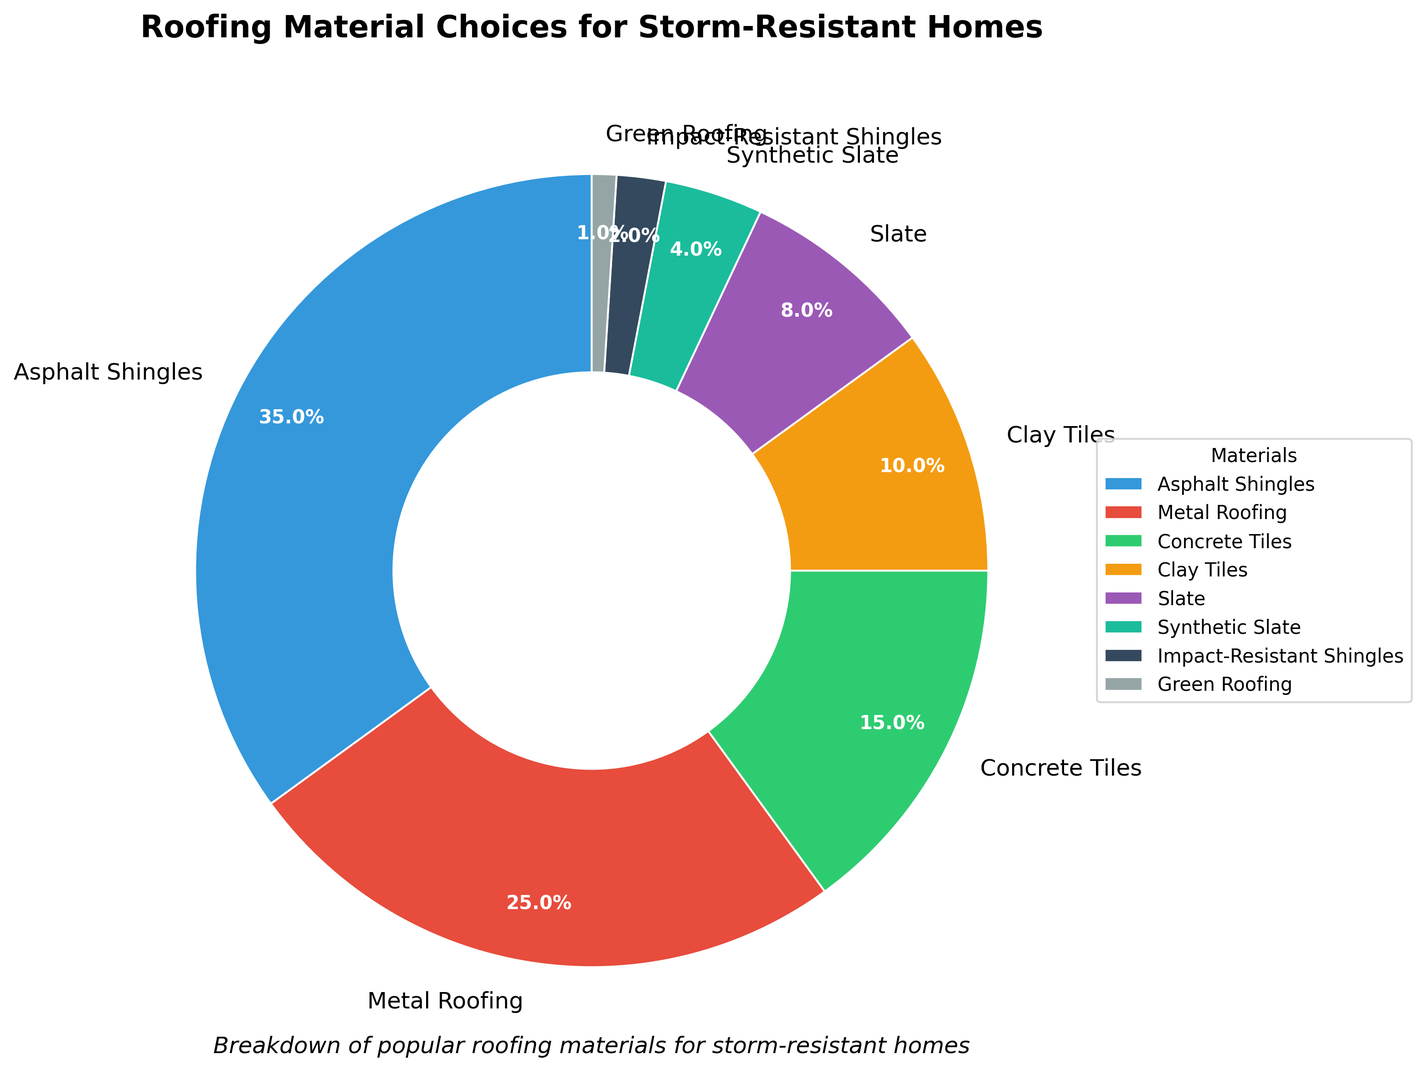What's the most popular material choice for storm-resistant homes? The figure's largest wedge indicates the most popular roofing material, which is labeled accordingly. Asphalt Shingles cover the largest area in the pie chart.
Answer: Asphalt Shingles Which roofing material occupies the third-largest percentage in the chart? To find the third-largest segment, first identify the largest (Asphalt Shingles), followed by the second-largest (Metal Roofing). The third-largest is the next in size, labeled as Concrete Tiles.
Answer: Concrete Tiles Which roofing material is twice as prevalent as Slate? To determine which material is twice as prevalent as Slate, we find Slate's percentage (8%). Doubling this gives 16%, but none me, the closest is Concrete Tiles at 15%, followed closely by Metal Roofing at 25%. Metal Roofing is more than twice as prevalent as Slate.
Answer: Metal Roofing Is Green Roofing more common than Synthetic Slate? We compare the sections labeled Green Roofing and Synthetic Slate. Green Roofing occupies 1%, while Synthetic Slate occupies 4%. Hence, Synthetic Slate is more common than Green Roofing.
Answer: No By how much does the percentage of Asphalt Shingles exceed that of Metal Roofing? The percentage for Asphalt Shingles is 35%, and for Metal Roofing, it's 25%. Subtract Metal Roofing's percentage from Asphalt Shingles'. The difference is 35% - 25%.
Answer: 10% What is the combined percentage of Concrete Tiles and Clay Tiles? Add the percentages of Concrete Tiles (15%) and Clay Tiles (10%). The sum is 15% + 10%.
Answer: 25% Which material ranks lowest in popularity among the choices? The smallest wedge represents the least popular material. The chart shows that Green Roofing is labeled with the smallest percentage.
Answer: Green Roofing What percentage do Impact-Resistant Shingles contribute to the chart? The section labeled Impact-Resistant Shingles indicates its percentage contribution.
Answer: 2% How does the percentage of Slate compare with Synthetic Slate? Compare the sections labeled Slate and Synthetic Slate. Slate takes up 8%, while Synthetic Slate takes up 4%. Therefore, Slate's percentage is double that of Synthetic Slate.
Answer: Slate is greater What's the total percentage of the three least common materials? Identify the three smallest percentage sections: Green Roofing (1%), Impact-Resistant Shingles (2%), and Synthetic Slate (4%). Add these percentages: 1% + 2% + 4%.
Answer: 7% 